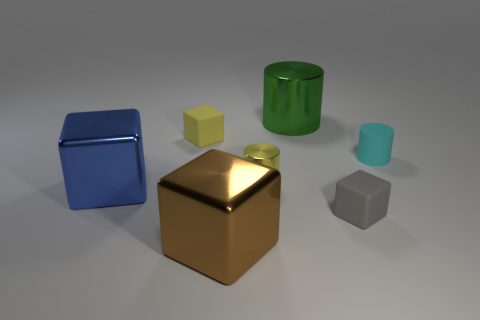Subtract 1 cylinders. How many cylinders are left? 2 Subtract all cyan blocks. Subtract all blue spheres. How many blocks are left? 4 Add 3 gray matte things. How many objects exist? 10 Subtract all blocks. How many objects are left? 3 Subtract 0 brown cylinders. How many objects are left? 7 Subtract all large red metal cubes. Subtract all rubber things. How many objects are left? 4 Add 3 big metallic cubes. How many big metallic cubes are left? 5 Add 5 large red balls. How many large red balls exist? 5 